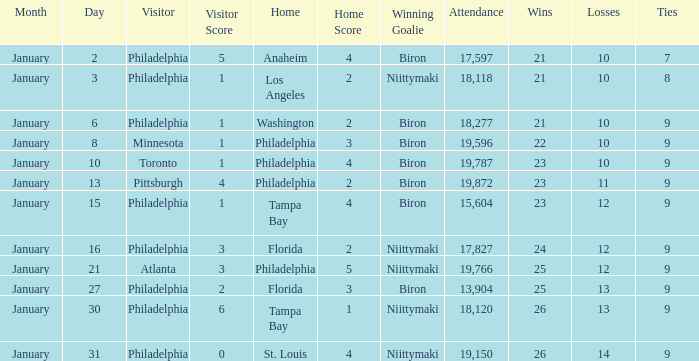What is the decision of the game on January 13? Biron. 